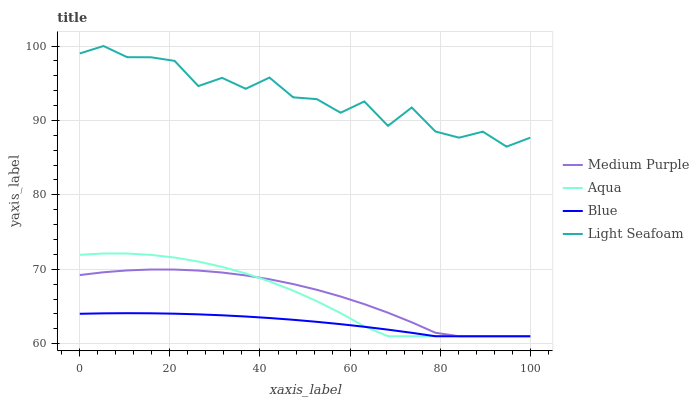Does Blue have the minimum area under the curve?
Answer yes or no. Yes. Does Light Seafoam have the maximum area under the curve?
Answer yes or no. Yes. Does Light Seafoam have the minimum area under the curve?
Answer yes or no. No. Does Blue have the maximum area under the curve?
Answer yes or no. No. Is Blue the smoothest?
Answer yes or no. Yes. Is Light Seafoam the roughest?
Answer yes or no. Yes. Is Light Seafoam the smoothest?
Answer yes or no. No. Is Blue the roughest?
Answer yes or no. No. Does Light Seafoam have the lowest value?
Answer yes or no. No. Does Blue have the highest value?
Answer yes or no. No. Is Medium Purple less than Light Seafoam?
Answer yes or no. Yes. Is Light Seafoam greater than Medium Purple?
Answer yes or no. Yes. Does Medium Purple intersect Light Seafoam?
Answer yes or no. No. 